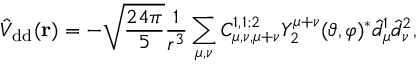<formula> <loc_0><loc_0><loc_500><loc_500>\hat { V } _ { d d } ( r ) = - \sqrt { \frac { 2 4 \pi } { 5 } } \frac { 1 } { r ^ { 3 } } \sum _ { \mu , \nu } C _ { \mu , \nu , \mu + \nu } ^ { 1 , 1 ; 2 } Y _ { 2 } ^ { \mu + \nu } ( \vartheta , \varphi ) ^ { * } \hat { d } _ { \mu } ^ { 1 } \hat { d } _ { \nu } ^ { 2 } ,</formula> 